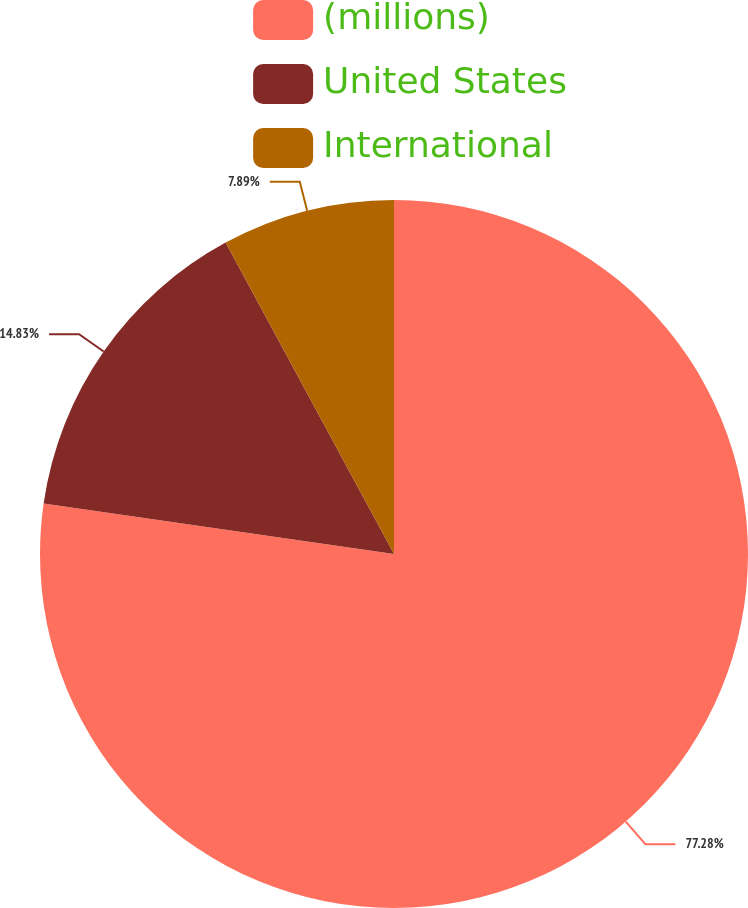Convert chart. <chart><loc_0><loc_0><loc_500><loc_500><pie_chart><fcel>(millions)<fcel>United States<fcel>International<nl><fcel>77.28%<fcel>14.83%<fcel>7.89%<nl></chart> 